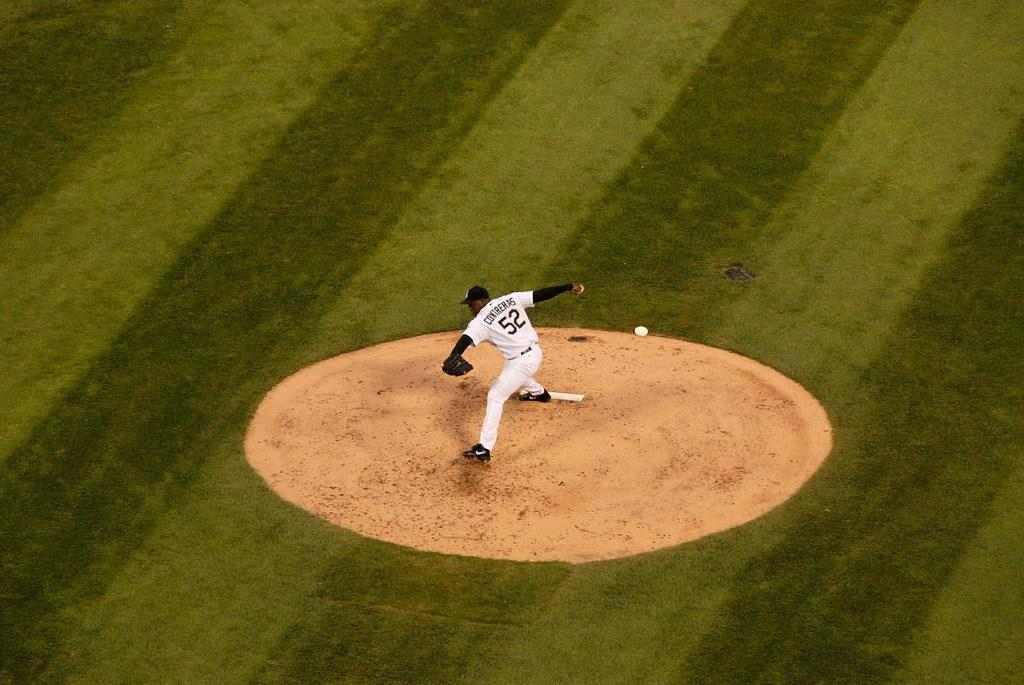<image>
Write a terse but informative summary of the picture. a pitchers mound in a baseball game with a pitcher wearing a 52 jersey about to pitch 